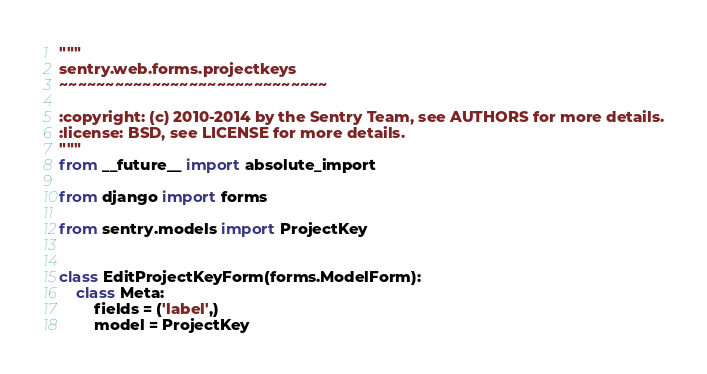Convert code to text. <code><loc_0><loc_0><loc_500><loc_500><_Python_>"""
sentry.web.forms.projectkeys
~~~~~~~~~~~~~~~~~~~~~~~~~~~~~

:copyright: (c) 2010-2014 by the Sentry Team, see AUTHORS for more details.
:license: BSD, see LICENSE for more details.
"""
from __future__ import absolute_import

from django import forms

from sentry.models import ProjectKey


class EditProjectKeyForm(forms.ModelForm):
    class Meta:
        fields = ('label',)
        model = ProjectKey
</code> 